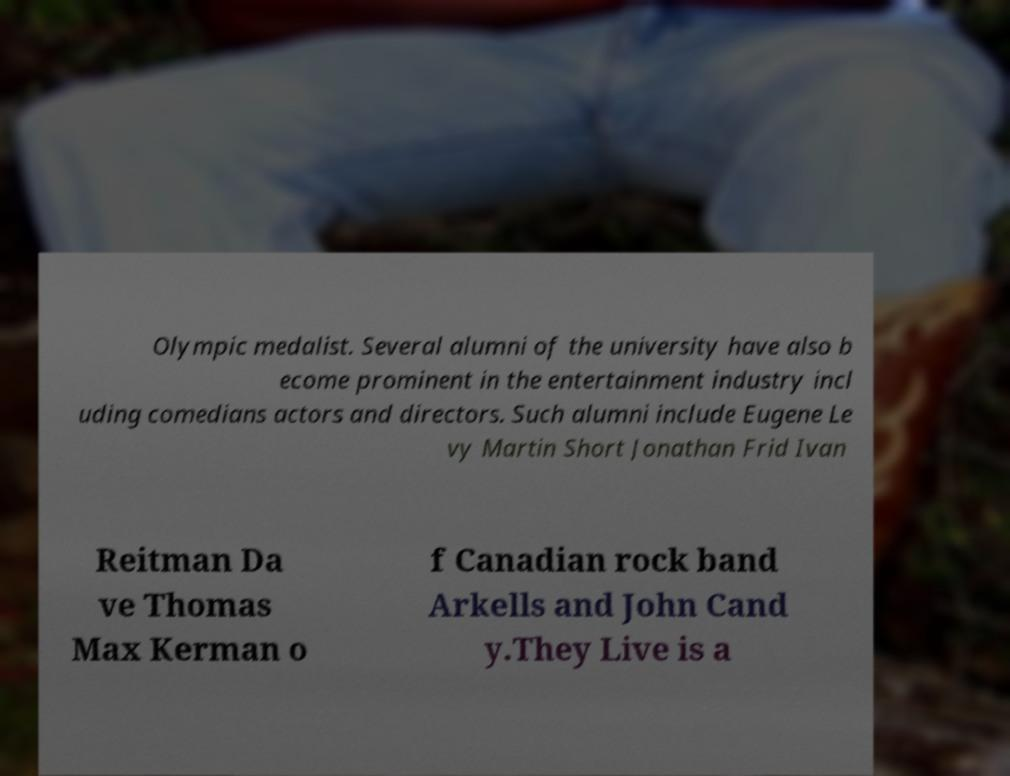There's text embedded in this image that I need extracted. Can you transcribe it verbatim? Olympic medalist. Several alumni of the university have also b ecome prominent in the entertainment industry incl uding comedians actors and directors. Such alumni include Eugene Le vy Martin Short Jonathan Frid Ivan Reitman Da ve Thomas Max Kerman o f Canadian rock band Arkells and John Cand y.They Live is a 